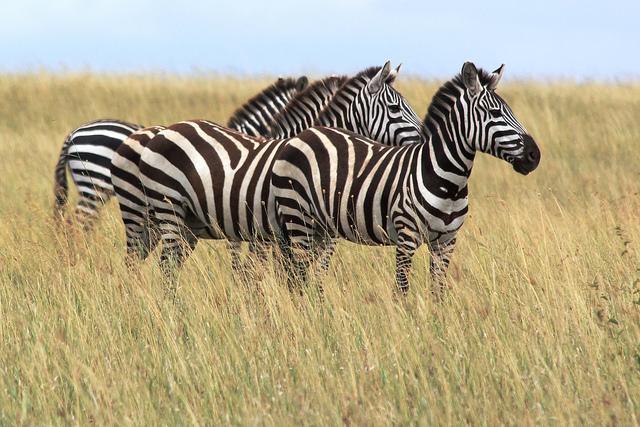How many zebras are there?
Give a very brief answer. 4. How many yellow buses are on the road?
Give a very brief answer. 0. 